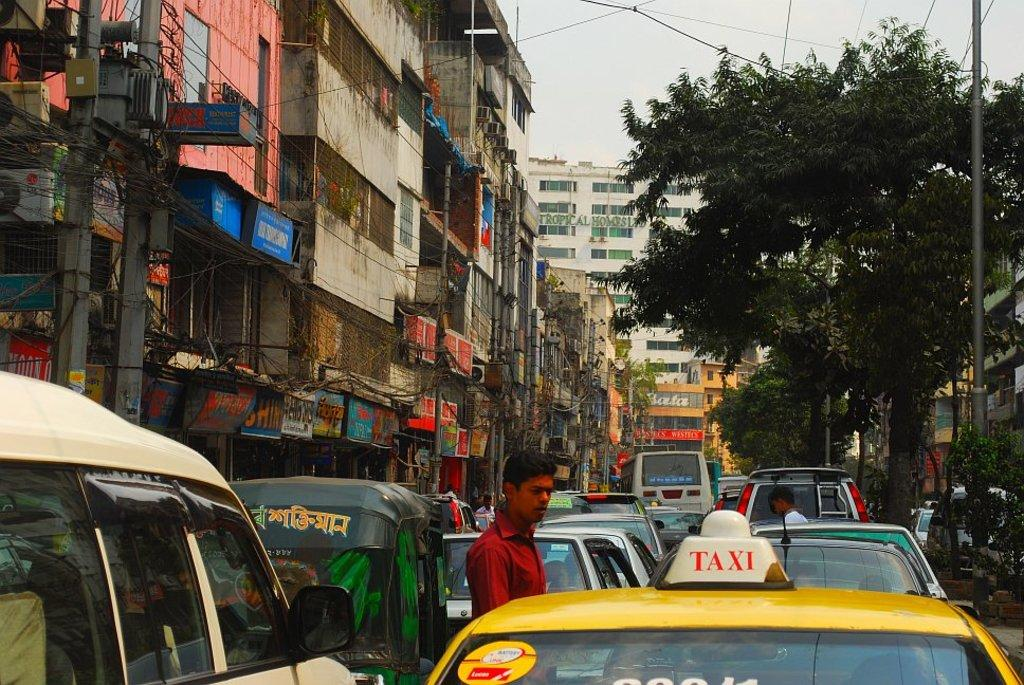<image>
Present a compact description of the photo's key features. a taxi that is outside among many other cars 